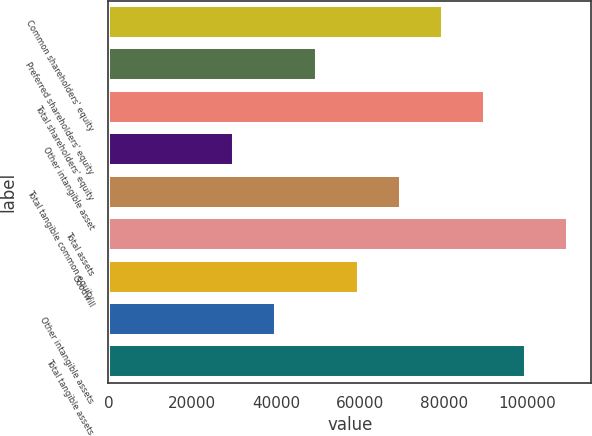<chart> <loc_0><loc_0><loc_500><loc_500><bar_chart><fcel>Common shareholders' equity<fcel>Preferred shareholders' equity<fcel>Total shareholders' equity<fcel>Other intangible asset<fcel>Total tangible common equity<fcel>Total assets<fcel>Goodwill<fcel>Other intangible assets<fcel>Total tangible assets<nl><fcel>79772.6<fcel>49860.6<fcel>89743.3<fcel>29919.2<fcel>69801.9<fcel>109685<fcel>59831.2<fcel>39889.9<fcel>99714<nl></chart> 